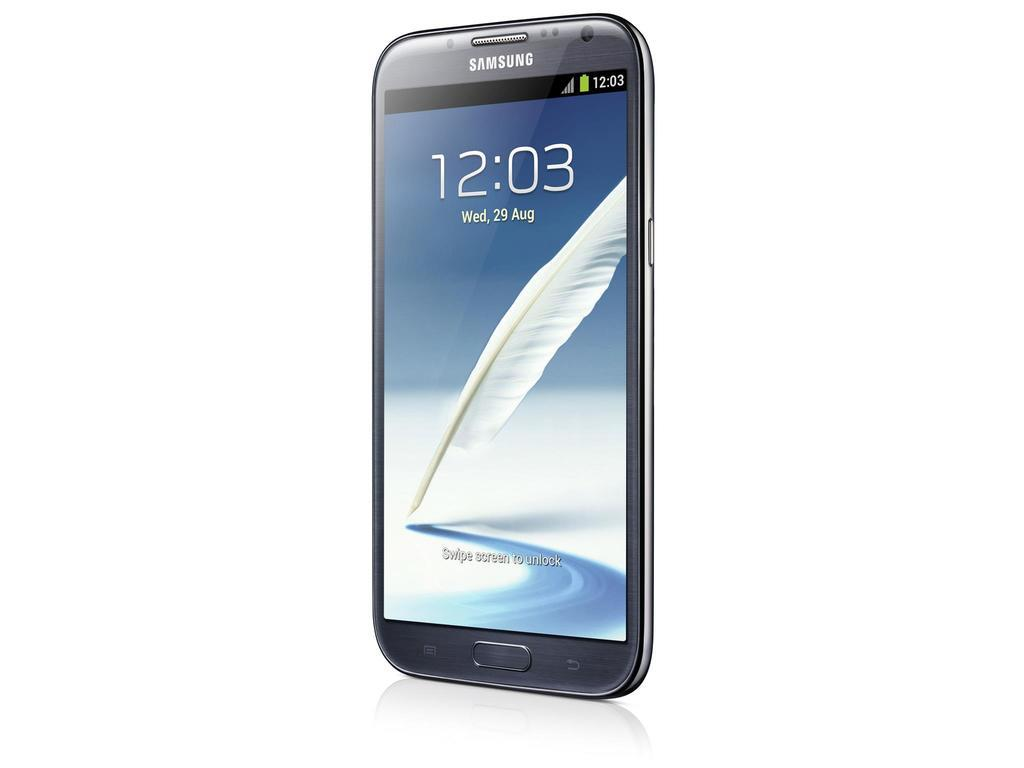<image>
Create a compact narrative representing the image presented. The Samsung phone has a picture of a white feather and the time on it. 